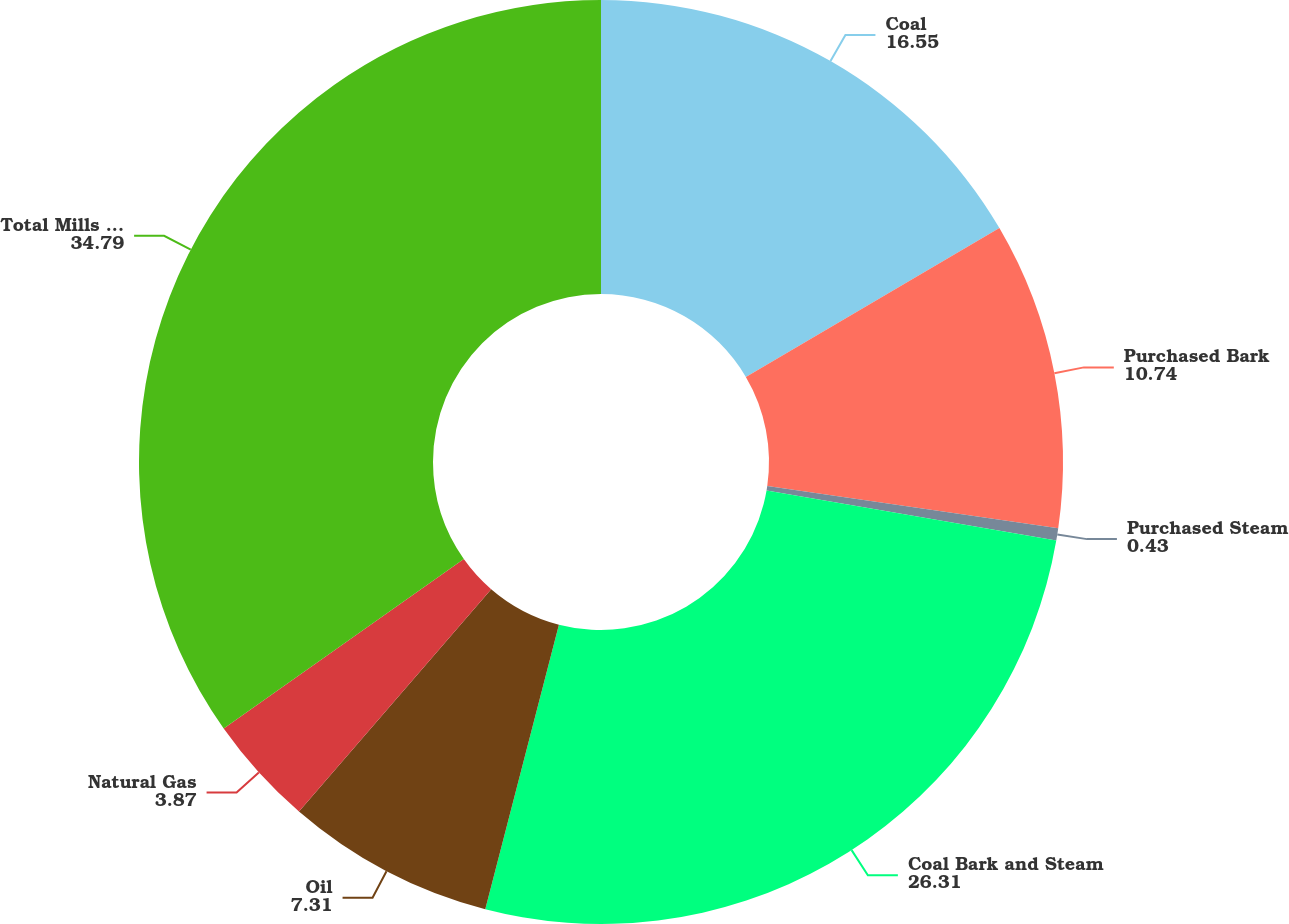<chart> <loc_0><loc_0><loc_500><loc_500><pie_chart><fcel>Coal<fcel>Purchased Bark<fcel>Purchased Steam<fcel>Coal Bark and Steam<fcel>Oil<fcel>Natural Gas<fcel>Total Mills Purchased Fuels 4<nl><fcel>16.55%<fcel>10.74%<fcel>0.43%<fcel>26.31%<fcel>7.31%<fcel>3.87%<fcel>34.79%<nl></chart> 